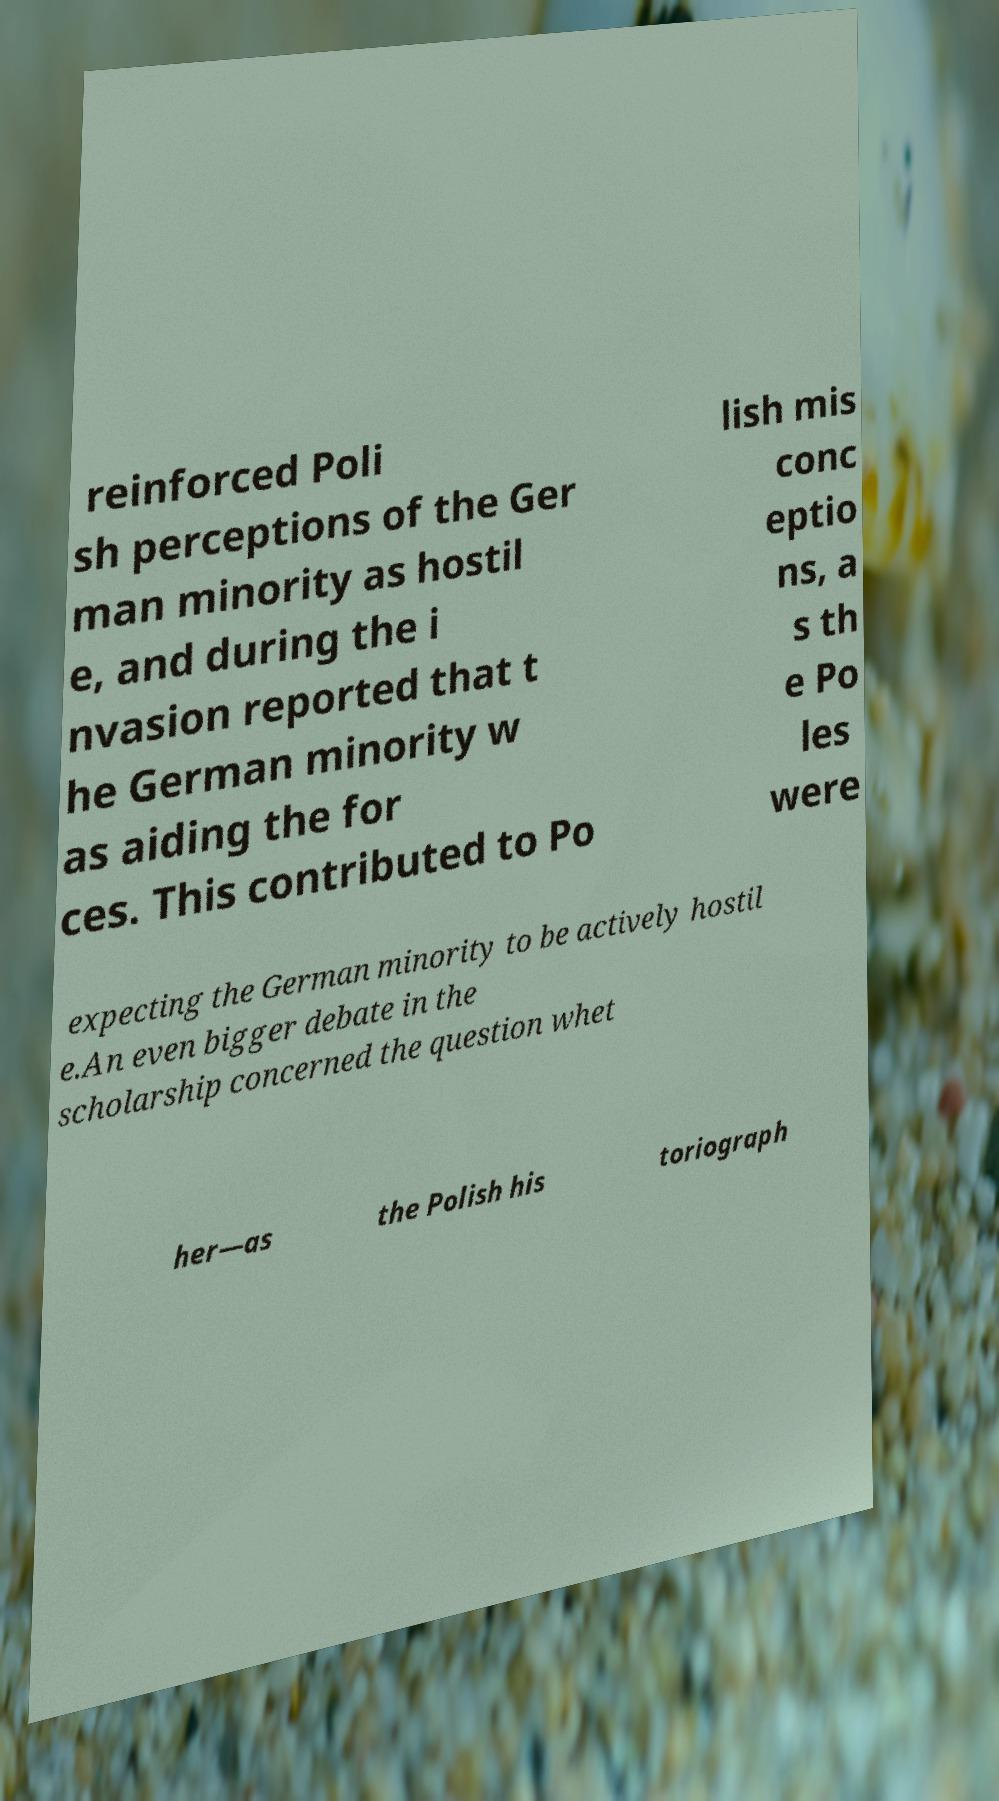Can you read and provide the text displayed in the image?This photo seems to have some interesting text. Can you extract and type it out for me? reinforced Poli sh perceptions of the Ger man minority as hostil e, and during the i nvasion reported that t he German minority w as aiding the for ces. This contributed to Po lish mis conc eptio ns, a s th e Po les were expecting the German minority to be actively hostil e.An even bigger debate in the scholarship concerned the question whet her—as the Polish his toriograph 